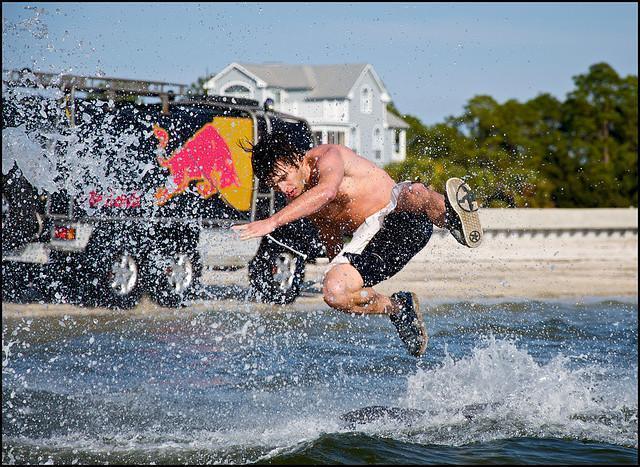What animal is the picture on the truck of?
From the following four choices, select the correct answer to address the question.
Options: Elephant, bull, condor, giraffe. Bull. 